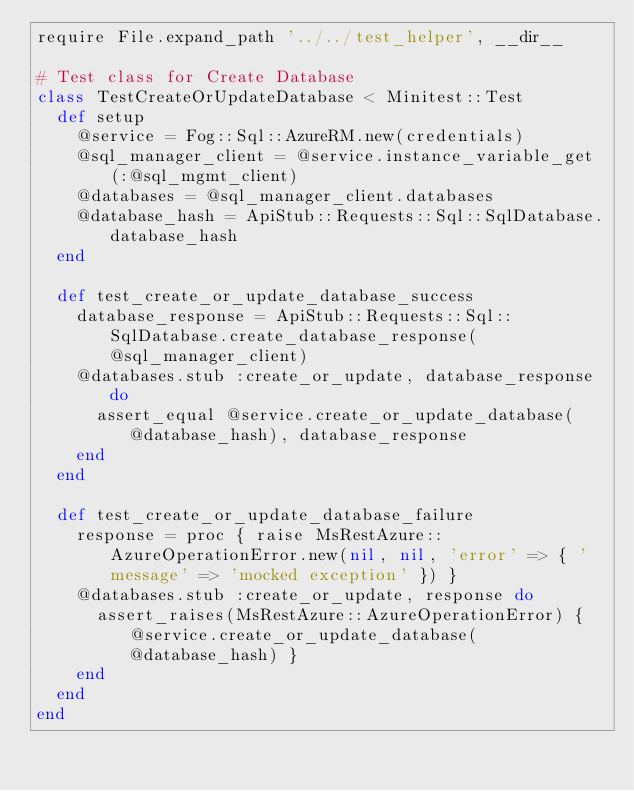<code> <loc_0><loc_0><loc_500><loc_500><_Ruby_>require File.expand_path '../../test_helper', __dir__

# Test class for Create Database
class TestCreateOrUpdateDatabase < Minitest::Test
  def setup
    @service = Fog::Sql::AzureRM.new(credentials)
    @sql_manager_client = @service.instance_variable_get(:@sql_mgmt_client)
    @databases = @sql_manager_client.databases
    @database_hash = ApiStub::Requests::Sql::SqlDatabase.database_hash
  end

  def test_create_or_update_database_success
    database_response = ApiStub::Requests::Sql::SqlDatabase.create_database_response(@sql_manager_client)
    @databases.stub :create_or_update, database_response do
      assert_equal @service.create_or_update_database(@database_hash), database_response
    end
  end

  def test_create_or_update_database_failure
    response = proc { raise MsRestAzure::AzureOperationError.new(nil, nil, 'error' => { 'message' => 'mocked exception' }) }
    @databases.stub :create_or_update, response do
      assert_raises(MsRestAzure::AzureOperationError) { @service.create_or_update_database(@database_hash) }
    end
  end
end
</code> 